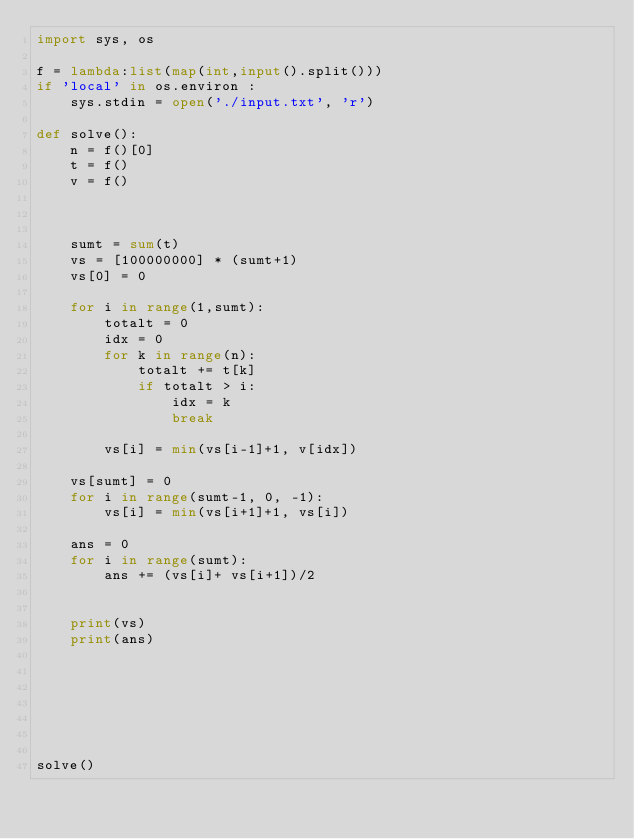<code> <loc_0><loc_0><loc_500><loc_500><_Python_>import sys, os

f = lambda:list(map(int,input().split()))
if 'local' in os.environ :
    sys.stdin = open('./input.txt', 'r')

def solve():
    n = f()[0]
    t = f()
    v = f()
    


    sumt = sum(t)
    vs = [100000000] * (sumt+1)
    vs[0] = 0

    for i in range(1,sumt):
        totalt = 0
        idx = 0
        for k in range(n):
            totalt += t[k]
            if totalt > i:
                idx = k
                break

        vs[i] = min(vs[i-1]+1, v[idx])

    vs[sumt] = 0
    for i in range(sumt-1, 0, -1):
        vs[i] = min(vs[i+1]+1, vs[i])

    ans = 0
    for i in range(sumt):
        ans += (vs[i]+ vs[i+1])/2


    print(vs)
    print(ans)
    


    



solve()
</code> 